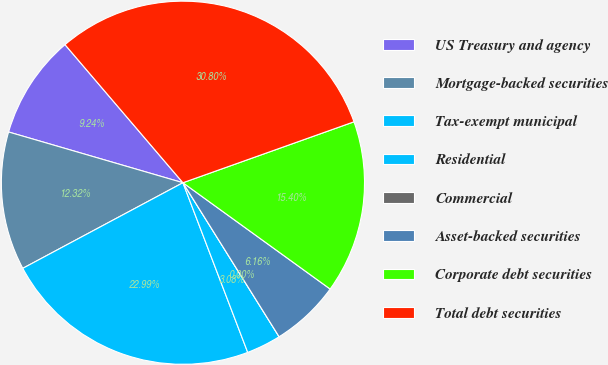<chart> <loc_0><loc_0><loc_500><loc_500><pie_chart><fcel>US Treasury and agency<fcel>Mortgage-backed securities<fcel>Tax-exempt municipal<fcel>Residential<fcel>Commercial<fcel>Asset-backed securities<fcel>Corporate debt securities<fcel>Total debt securities<nl><fcel>9.24%<fcel>12.32%<fcel>22.99%<fcel>3.08%<fcel>0.0%<fcel>6.16%<fcel>15.4%<fcel>30.8%<nl></chart> 